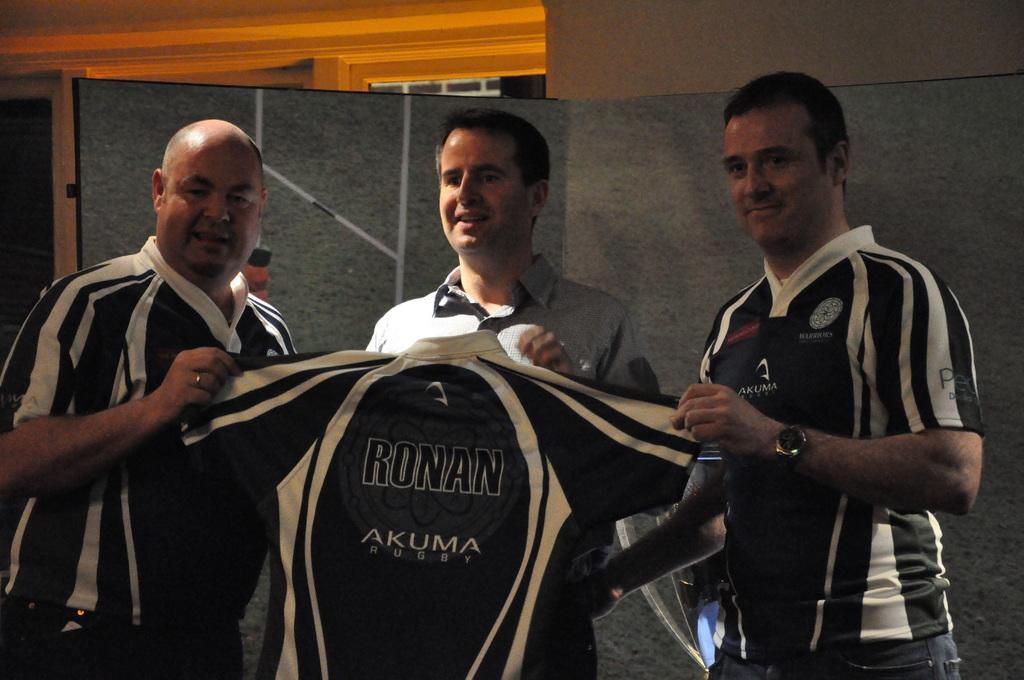<image>
Share a concise interpretation of the image provided. Three men hold a shirt bearing the words RONAN AKUMA QUEST on it. 